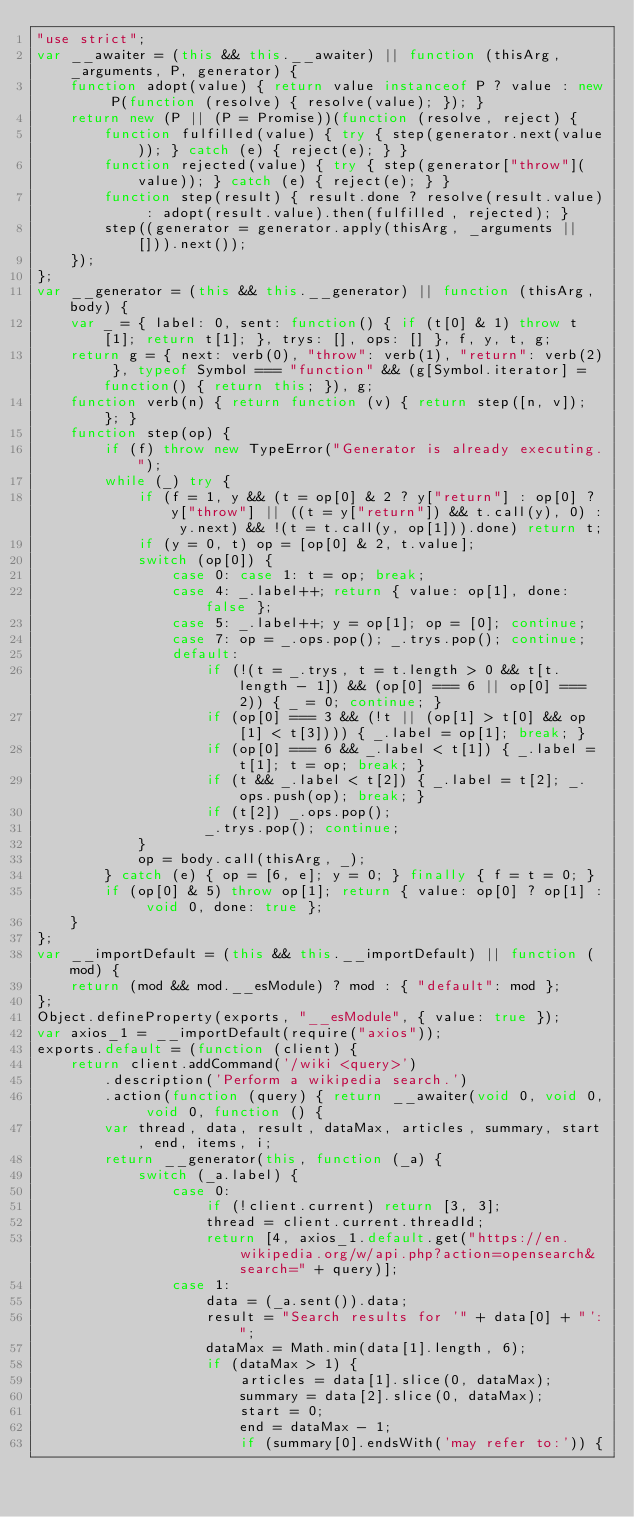Convert code to text. <code><loc_0><loc_0><loc_500><loc_500><_JavaScript_>"use strict";
var __awaiter = (this && this.__awaiter) || function (thisArg, _arguments, P, generator) {
    function adopt(value) { return value instanceof P ? value : new P(function (resolve) { resolve(value); }); }
    return new (P || (P = Promise))(function (resolve, reject) {
        function fulfilled(value) { try { step(generator.next(value)); } catch (e) { reject(e); } }
        function rejected(value) { try { step(generator["throw"](value)); } catch (e) { reject(e); } }
        function step(result) { result.done ? resolve(result.value) : adopt(result.value).then(fulfilled, rejected); }
        step((generator = generator.apply(thisArg, _arguments || [])).next());
    });
};
var __generator = (this && this.__generator) || function (thisArg, body) {
    var _ = { label: 0, sent: function() { if (t[0] & 1) throw t[1]; return t[1]; }, trys: [], ops: [] }, f, y, t, g;
    return g = { next: verb(0), "throw": verb(1), "return": verb(2) }, typeof Symbol === "function" && (g[Symbol.iterator] = function() { return this; }), g;
    function verb(n) { return function (v) { return step([n, v]); }; }
    function step(op) {
        if (f) throw new TypeError("Generator is already executing.");
        while (_) try {
            if (f = 1, y && (t = op[0] & 2 ? y["return"] : op[0] ? y["throw"] || ((t = y["return"]) && t.call(y), 0) : y.next) && !(t = t.call(y, op[1])).done) return t;
            if (y = 0, t) op = [op[0] & 2, t.value];
            switch (op[0]) {
                case 0: case 1: t = op; break;
                case 4: _.label++; return { value: op[1], done: false };
                case 5: _.label++; y = op[1]; op = [0]; continue;
                case 7: op = _.ops.pop(); _.trys.pop(); continue;
                default:
                    if (!(t = _.trys, t = t.length > 0 && t[t.length - 1]) && (op[0] === 6 || op[0] === 2)) { _ = 0; continue; }
                    if (op[0] === 3 && (!t || (op[1] > t[0] && op[1] < t[3]))) { _.label = op[1]; break; }
                    if (op[0] === 6 && _.label < t[1]) { _.label = t[1]; t = op; break; }
                    if (t && _.label < t[2]) { _.label = t[2]; _.ops.push(op); break; }
                    if (t[2]) _.ops.pop();
                    _.trys.pop(); continue;
            }
            op = body.call(thisArg, _);
        } catch (e) { op = [6, e]; y = 0; } finally { f = t = 0; }
        if (op[0] & 5) throw op[1]; return { value: op[0] ? op[1] : void 0, done: true };
    }
};
var __importDefault = (this && this.__importDefault) || function (mod) {
    return (mod && mod.__esModule) ? mod : { "default": mod };
};
Object.defineProperty(exports, "__esModule", { value: true });
var axios_1 = __importDefault(require("axios"));
exports.default = (function (client) {
    return client.addCommand('/wiki <query>')
        .description('Perform a wikipedia search.')
        .action(function (query) { return __awaiter(void 0, void 0, void 0, function () {
        var thread, data, result, dataMax, articles, summary, start, end, items, i;
        return __generator(this, function (_a) {
            switch (_a.label) {
                case 0:
                    if (!client.current) return [3, 3];
                    thread = client.current.threadId;
                    return [4, axios_1.default.get("https://en.wikipedia.org/w/api.php?action=opensearch&search=" + query)];
                case 1:
                    data = (_a.sent()).data;
                    result = "Search results for '" + data[0] + "':";
                    dataMax = Math.min(data[1].length, 6);
                    if (dataMax > 1) {
                        articles = data[1].slice(0, dataMax);
                        summary = data[2].slice(0, dataMax);
                        start = 0;
                        end = dataMax - 1;
                        if (summary[0].endsWith('may refer to:')) {</code> 